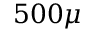<formula> <loc_0><loc_0><loc_500><loc_500>5 0 0 \mu</formula> 